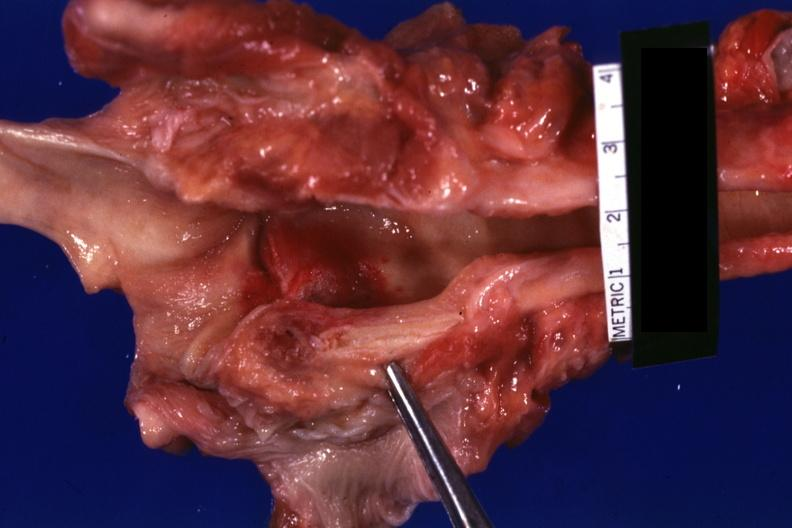what does this image show?
Answer the question using a single word or phrase. Large ulcer on right cord with hyperemia case of leukemia with candida infection 